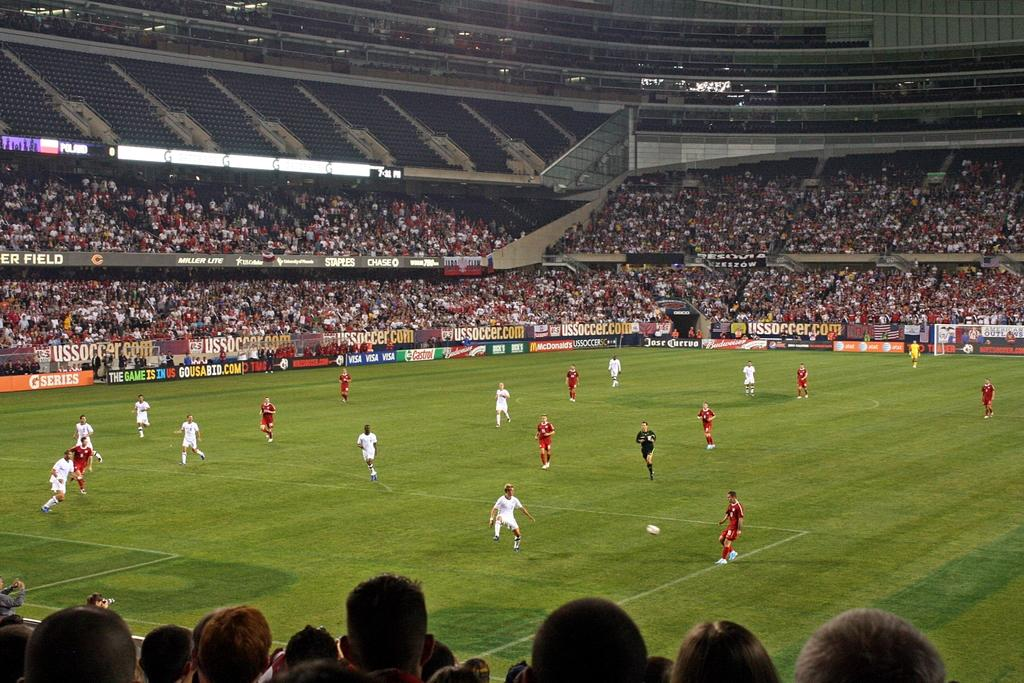<image>
Relay a brief, clear account of the picture shown. A packed soccer stadium has banner ads for items such as Gatorade and stores like Staples. 